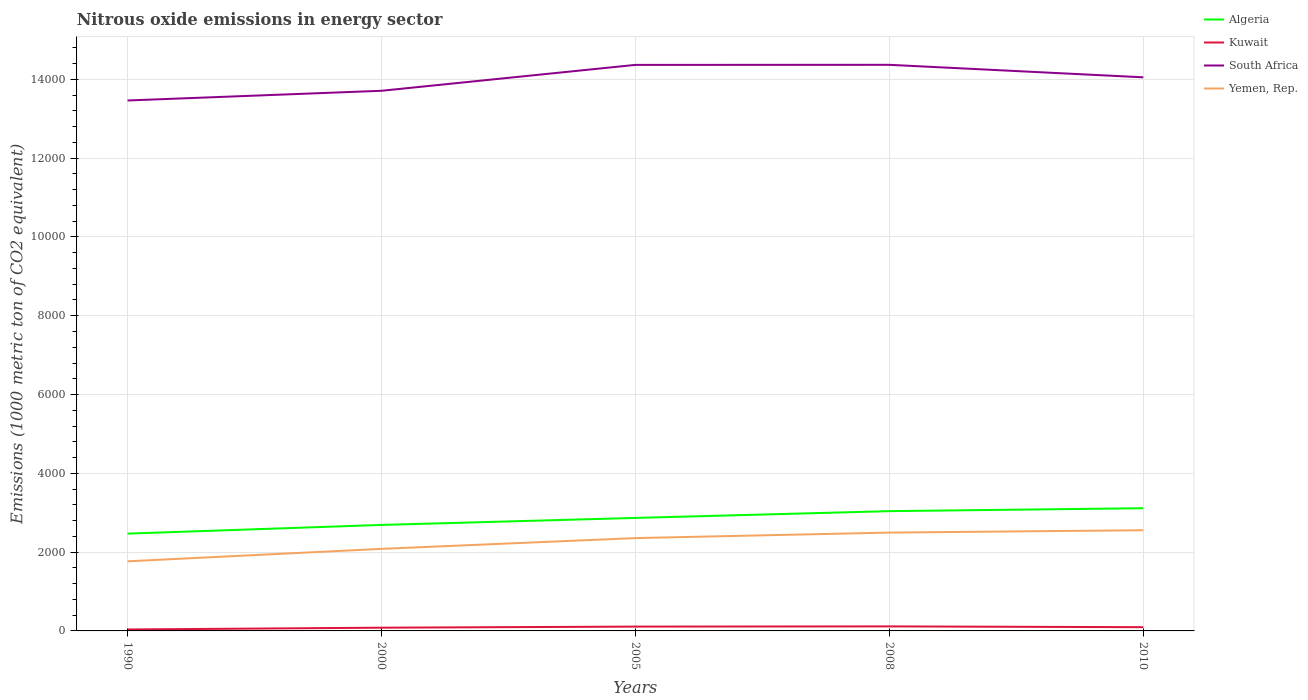Across all years, what is the maximum amount of nitrous oxide emitted in Algeria?
Give a very brief answer. 2469.5. What is the total amount of nitrous oxide emitted in Algeria in the graph?
Provide a succinct answer. -74.5. What is the difference between the highest and the second highest amount of nitrous oxide emitted in Algeria?
Provide a succinct answer. 645.1. How many lines are there?
Offer a very short reply. 4. Are the values on the major ticks of Y-axis written in scientific E-notation?
Your response must be concise. No. Does the graph contain any zero values?
Offer a very short reply. No. Where does the legend appear in the graph?
Your answer should be very brief. Top right. How are the legend labels stacked?
Keep it short and to the point. Vertical. What is the title of the graph?
Offer a terse response. Nitrous oxide emissions in energy sector. Does "Bahrain" appear as one of the legend labels in the graph?
Provide a short and direct response. No. What is the label or title of the X-axis?
Your answer should be compact. Years. What is the label or title of the Y-axis?
Give a very brief answer. Emissions (1000 metric ton of CO2 equivalent). What is the Emissions (1000 metric ton of CO2 equivalent) of Algeria in 1990?
Ensure brevity in your answer.  2469.5. What is the Emissions (1000 metric ton of CO2 equivalent) in Kuwait in 1990?
Provide a succinct answer. 36.7. What is the Emissions (1000 metric ton of CO2 equivalent) of South Africa in 1990?
Make the answer very short. 1.35e+04. What is the Emissions (1000 metric ton of CO2 equivalent) in Yemen, Rep. in 1990?
Make the answer very short. 1766.7. What is the Emissions (1000 metric ton of CO2 equivalent) of Algeria in 2000?
Your answer should be very brief. 2690.4. What is the Emissions (1000 metric ton of CO2 equivalent) in Kuwait in 2000?
Make the answer very short. 81.9. What is the Emissions (1000 metric ton of CO2 equivalent) in South Africa in 2000?
Offer a terse response. 1.37e+04. What is the Emissions (1000 metric ton of CO2 equivalent) in Yemen, Rep. in 2000?
Offer a terse response. 2082.9. What is the Emissions (1000 metric ton of CO2 equivalent) in Algeria in 2005?
Give a very brief answer. 2868.2. What is the Emissions (1000 metric ton of CO2 equivalent) of Kuwait in 2005?
Your answer should be compact. 109.8. What is the Emissions (1000 metric ton of CO2 equivalent) in South Africa in 2005?
Make the answer very short. 1.44e+04. What is the Emissions (1000 metric ton of CO2 equivalent) in Yemen, Rep. in 2005?
Provide a short and direct response. 2356. What is the Emissions (1000 metric ton of CO2 equivalent) of Algeria in 2008?
Give a very brief answer. 3040.1. What is the Emissions (1000 metric ton of CO2 equivalent) of Kuwait in 2008?
Make the answer very short. 114.9. What is the Emissions (1000 metric ton of CO2 equivalent) of South Africa in 2008?
Make the answer very short. 1.44e+04. What is the Emissions (1000 metric ton of CO2 equivalent) of Yemen, Rep. in 2008?
Provide a succinct answer. 2495.7. What is the Emissions (1000 metric ton of CO2 equivalent) in Algeria in 2010?
Your answer should be compact. 3114.6. What is the Emissions (1000 metric ton of CO2 equivalent) of Kuwait in 2010?
Keep it short and to the point. 94.9. What is the Emissions (1000 metric ton of CO2 equivalent) of South Africa in 2010?
Your answer should be compact. 1.41e+04. What is the Emissions (1000 metric ton of CO2 equivalent) of Yemen, Rep. in 2010?
Provide a succinct answer. 2555.7. Across all years, what is the maximum Emissions (1000 metric ton of CO2 equivalent) of Algeria?
Your answer should be compact. 3114.6. Across all years, what is the maximum Emissions (1000 metric ton of CO2 equivalent) of Kuwait?
Your answer should be compact. 114.9. Across all years, what is the maximum Emissions (1000 metric ton of CO2 equivalent) of South Africa?
Give a very brief answer. 1.44e+04. Across all years, what is the maximum Emissions (1000 metric ton of CO2 equivalent) in Yemen, Rep.?
Provide a succinct answer. 2555.7. Across all years, what is the minimum Emissions (1000 metric ton of CO2 equivalent) in Algeria?
Offer a very short reply. 2469.5. Across all years, what is the minimum Emissions (1000 metric ton of CO2 equivalent) in Kuwait?
Offer a very short reply. 36.7. Across all years, what is the minimum Emissions (1000 metric ton of CO2 equivalent) in South Africa?
Offer a very short reply. 1.35e+04. Across all years, what is the minimum Emissions (1000 metric ton of CO2 equivalent) in Yemen, Rep.?
Give a very brief answer. 1766.7. What is the total Emissions (1000 metric ton of CO2 equivalent) in Algeria in the graph?
Ensure brevity in your answer.  1.42e+04. What is the total Emissions (1000 metric ton of CO2 equivalent) in Kuwait in the graph?
Your response must be concise. 438.2. What is the total Emissions (1000 metric ton of CO2 equivalent) in South Africa in the graph?
Your answer should be compact. 7.00e+04. What is the total Emissions (1000 metric ton of CO2 equivalent) in Yemen, Rep. in the graph?
Ensure brevity in your answer.  1.13e+04. What is the difference between the Emissions (1000 metric ton of CO2 equivalent) in Algeria in 1990 and that in 2000?
Give a very brief answer. -220.9. What is the difference between the Emissions (1000 metric ton of CO2 equivalent) in Kuwait in 1990 and that in 2000?
Give a very brief answer. -45.2. What is the difference between the Emissions (1000 metric ton of CO2 equivalent) in South Africa in 1990 and that in 2000?
Ensure brevity in your answer.  -246.5. What is the difference between the Emissions (1000 metric ton of CO2 equivalent) of Yemen, Rep. in 1990 and that in 2000?
Provide a short and direct response. -316.2. What is the difference between the Emissions (1000 metric ton of CO2 equivalent) of Algeria in 1990 and that in 2005?
Provide a short and direct response. -398.7. What is the difference between the Emissions (1000 metric ton of CO2 equivalent) of Kuwait in 1990 and that in 2005?
Provide a succinct answer. -73.1. What is the difference between the Emissions (1000 metric ton of CO2 equivalent) of South Africa in 1990 and that in 2005?
Provide a short and direct response. -903.7. What is the difference between the Emissions (1000 metric ton of CO2 equivalent) of Yemen, Rep. in 1990 and that in 2005?
Keep it short and to the point. -589.3. What is the difference between the Emissions (1000 metric ton of CO2 equivalent) in Algeria in 1990 and that in 2008?
Provide a short and direct response. -570.6. What is the difference between the Emissions (1000 metric ton of CO2 equivalent) of Kuwait in 1990 and that in 2008?
Your answer should be compact. -78.2. What is the difference between the Emissions (1000 metric ton of CO2 equivalent) in South Africa in 1990 and that in 2008?
Offer a very short reply. -905.7. What is the difference between the Emissions (1000 metric ton of CO2 equivalent) in Yemen, Rep. in 1990 and that in 2008?
Offer a terse response. -729. What is the difference between the Emissions (1000 metric ton of CO2 equivalent) in Algeria in 1990 and that in 2010?
Your answer should be very brief. -645.1. What is the difference between the Emissions (1000 metric ton of CO2 equivalent) in Kuwait in 1990 and that in 2010?
Keep it short and to the point. -58.2. What is the difference between the Emissions (1000 metric ton of CO2 equivalent) of South Africa in 1990 and that in 2010?
Give a very brief answer. -588.2. What is the difference between the Emissions (1000 metric ton of CO2 equivalent) of Yemen, Rep. in 1990 and that in 2010?
Your answer should be very brief. -789. What is the difference between the Emissions (1000 metric ton of CO2 equivalent) of Algeria in 2000 and that in 2005?
Offer a very short reply. -177.8. What is the difference between the Emissions (1000 metric ton of CO2 equivalent) in Kuwait in 2000 and that in 2005?
Your answer should be compact. -27.9. What is the difference between the Emissions (1000 metric ton of CO2 equivalent) of South Africa in 2000 and that in 2005?
Keep it short and to the point. -657.2. What is the difference between the Emissions (1000 metric ton of CO2 equivalent) in Yemen, Rep. in 2000 and that in 2005?
Your answer should be very brief. -273.1. What is the difference between the Emissions (1000 metric ton of CO2 equivalent) of Algeria in 2000 and that in 2008?
Provide a succinct answer. -349.7. What is the difference between the Emissions (1000 metric ton of CO2 equivalent) of Kuwait in 2000 and that in 2008?
Give a very brief answer. -33. What is the difference between the Emissions (1000 metric ton of CO2 equivalent) of South Africa in 2000 and that in 2008?
Your response must be concise. -659.2. What is the difference between the Emissions (1000 metric ton of CO2 equivalent) of Yemen, Rep. in 2000 and that in 2008?
Make the answer very short. -412.8. What is the difference between the Emissions (1000 metric ton of CO2 equivalent) of Algeria in 2000 and that in 2010?
Your answer should be compact. -424.2. What is the difference between the Emissions (1000 metric ton of CO2 equivalent) of South Africa in 2000 and that in 2010?
Offer a very short reply. -341.7. What is the difference between the Emissions (1000 metric ton of CO2 equivalent) in Yemen, Rep. in 2000 and that in 2010?
Offer a terse response. -472.8. What is the difference between the Emissions (1000 metric ton of CO2 equivalent) of Algeria in 2005 and that in 2008?
Your response must be concise. -171.9. What is the difference between the Emissions (1000 metric ton of CO2 equivalent) of Kuwait in 2005 and that in 2008?
Ensure brevity in your answer.  -5.1. What is the difference between the Emissions (1000 metric ton of CO2 equivalent) in South Africa in 2005 and that in 2008?
Provide a succinct answer. -2. What is the difference between the Emissions (1000 metric ton of CO2 equivalent) of Yemen, Rep. in 2005 and that in 2008?
Offer a terse response. -139.7. What is the difference between the Emissions (1000 metric ton of CO2 equivalent) of Algeria in 2005 and that in 2010?
Offer a terse response. -246.4. What is the difference between the Emissions (1000 metric ton of CO2 equivalent) of Kuwait in 2005 and that in 2010?
Offer a terse response. 14.9. What is the difference between the Emissions (1000 metric ton of CO2 equivalent) in South Africa in 2005 and that in 2010?
Provide a succinct answer. 315.5. What is the difference between the Emissions (1000 metric ton of CO2 equivalent) of Yemen, Rep. in 2005 and that in 2010?
Make the answer very short. -199.7. What is the difference between the Emissions (1000 metric ton of CO2 equivalent) of Algeria in 2008 and that in 2010?
Make the answer very short. -74.5. What is the difference between the Emissions (1000 metric ton of CO2 equivalent) in Kuwait in 2008 and that in 2010?
Provide a short and direct response. 20. What is the difference between the Emissions (1000 metric ton of CO2 equivalent) in South Africa in 2008 and that in 2010?
Provide a succinct answer. 317.5. What is the difference between the Emissions (1000 metric ton of CO2 equivalent) of Yemen, Rep. in 2008 and that in 2010?
Provide a short and direct response. -60. What is the difference between the Emissions (1000 metric ton of CO2 equivalent) of Algeria in 1990 and the Emissions (1000 metric ton of CO2 equivalent) of Kuwait in 2000?
Offer a very short reply. 2387.6. What is the difference between the Emissions (1000 metric ton of CO2 equivalent) of Algeria in 1990 and the Emissions (1000 metric ton of CO2 equivalent) of South Africa in 2000?
Provide a short and direct response. -1.12e+04. What is the difference between the Emissions (1000 metric ton of CO2 equivalent) of Algeria in 1990 and the Emissions (1000 metric ton of CO2 equivalent) of Yemen, Rep. in 2000?
Give a very brief answer. 386.6. What is the difference between the Emissions (1000 metric ton of CO2 equivalent) of Kuwait in 1990 and the Emissions (1000 metric ton of CO2 equivalent) of South Africa in 2000?
Give a very brief answer. -1.37e+04. What is the difference between the Emissions (1000 metric ton of CO2 equivalent) in Kuwait in 1990 and the Emissions (1000 metric ton of CO2 equivalent) in Yemen, Rep. in 2000?
Provide a succinct answer. -2046.2. What is the difference between the Emissions (1000 metric ton of CO2 equivalent) of South Africa in 1990 and the Emissions (1000 metric ton of CO2 equivalent) of Yemen, Rep. in 2000?
Keep it short and to the point. 1.14e+04. What is the difference between the Emissions (1000 metric ton of CO2 equivalent) of Algeria in 1990 and the Emissions (1000 metric ton of CO2 equivalent) of Kuwait in 2005?
Make the answer very short. 2359.7. What is the difference between the Emissions (1000 metric ton of CO2 equivalent) in Algeria in 1990 and the Emissions (1000 metric ton of CO2 equivalent) in South Africa in 2005?
Make the answer very short. -1.19e+04. What is the difference between the Emissions (1000 metric ton of CO2 equivalent) of Algeria in 1990 and the Emissions (1000 metric ton of CO2 equivalent) of Yemen, Rep. in 2005?
Keep it short and to the point. 113.5. What is the difference between the Emissions (1000 metric ton of CO2 equivalent) in Kuwait in 1990 and the Emissions (1000 metric ton of CO2 equivalent) in South Africa in 2005?
Make the answer very short. -1.43e+04. What is the difference between the Emissions (1000 metric ton of CO2 equivalent) of Kuwait in 1990 and the Emissions (1000 metric ton of CO2 equivalent) of Yemen, Rep. in 2005?
Your answer should be very brief. -2319.3. What is the difference between the Emissions (1000 metric ton of CO2 equivalent) of South Africa in 1990 and the Emissions (1000 metric ton of CO2 equivalent) of Yemen, Rep. in 2005?
Provide a short and direct response. 1.11e+04. What is the difference between the Emissions (1000 metric ton of CO2 equivalent) of Algeria in 1990 and the Emissions (1000 metric ton of CO2 equivalent) of Kuwait in 2008?
Your answer should be compact. 2354.6. What is the difference between the Emissions (1000 metric ton of CO2 equivalent) in Algeria in 1990 and the Emissions (1000 metric ton of CO2 equivalent) in South Africa in 2008?
Make the answer very short. -1.19e+04. What is the difference between the Emissions (1000 metric ton of CO2 equivalent) of Algeria in 1990 and the Emissions (1000 metric ton of CO2 equivalent) of Yemen, Rep. in 2008?
Provide a succinct answer. -26.2. What is the difference between the Emissions (1000 metric ton of CO2 equivalent) of Kuwait in 1990 and the Emissions (1000 metric ton of CO2 equivalent) of South Africa in 2008?
Keep it short and to the point. -1.43e+04. What is the difference between the Emissions (1000 metric ton of CO2 equivalent) of Kuwait in 1990 and the Emissions (1000 metric ton of CO2 equivalent) of Yemen, Rep. in 2008?
Offer a terse response. -2459. What is the difference between the Emissions (1000 metric ton of CO2 equivalent) in South Africa in 1990 and the Emissions (1000 metric ton of CO2 equivalent) in Yemen, Rep. in 2008?
Provide a short and direct response. 1.10e+04. What is the difference between the Emissions (1000 metric ton of CO2 equivalent) in Algeria in 1990 and the Emissions (1000 metric ton of CO2 equivalent) in Kuwait in 2010?
Keep it short and to the point. 2374.6. What is the difference between the Emissions (1000 metric ton of CO2 equivalent) in Algeria in 1990 and the Emissions (1000 metric ton of CO2 equivalent) in South Africa in 2010?
Your answer should be very brief. -1.16e+04. What is the difference between the Emissions (1000 metric ton of CO2 equivalent) of Algeria in 1990 and the Emissions (1000 metric ton of CO2 equivalent) of Yemen, Rep. in 2010?
Offer a terse response. -86.2. What is the difference between the Emissions (1000 metric ton of CO2 equivalent) of Kuwait in 1990 and the Emissions (1000 metric ton of CO2 equivalent) of South Africa in 2010?
Your response must be concise. -1.40e+04. What is the difference between the Emissions (1000 metric ton of CO2 equivalent) in Kuwait in 1990 and the Emissions (1000 metric ton of CO2 equivalent) in Yemen, Rep. in 2010?
Your answer should be compact. -2519. What is the difference between the Emissions (1000 metric ton of CO2 equivalent) of South Africa in 1990 and the Emissions (1000 metric ton of CO2 equivalent) of Yemen, Rep. in 2010?
Your answer should be very brief. 1.09e+04. What is the difference between the Emissions (1000 metric ton of CO2 equivalent) of Algeria in 2000 and the Emissions (1000 metric ton of CO2 equivalent) of Kuwait in 2005?
Give a very brief answer. 2580.6. What is the difference between the Emissions (1000 metric ton of CO2 equivalent) of Algeria in 2000 and the Emissions (1000 metric ton of CO2 equivalent) of South Africa in 2005?
Offer a terse response. -1.17e+04. What is the difference between the Emissions (1000 metric ton of CO2 equivalent) in Algeria in 2000 and the Emissions (1000 metric ton of CO2 equivalent) in Yemen, Rep. in 2005?
Your answer should be very brief. 334.4. What is the difference between the Emissions (1000 metric ton of CO2 equivalent) in Kuwait in 2000 and the Emissions (1000 metric ton of CO2 equivalent) in South Africa in 2005?
Provide a succinct answer. -1.43e+04. What is the difference between the Emissions (1000 metric ton of CO2 equivalent) of Kuwait in 2000 and the Emissions (1000 metric ton of CO2 equivalent) of Yemen, Rep. in 2005?
Your answer should be compact. -2274.1. What is the difference between the Emissions (1000 metric ton of CO2 equivalent) of South Africa in 2000 and the Emissions (1000 metric ton of CO2 equivalent) of Yemen, Rep. in 2005?
Your response must be concise. 1.14e+04. What is the difference between the Emissions (1000 metric ton of CO2 equivalent) in Algeria in 2000 and the Emissions (1000 metric ton of CO2 equivalent) in Kuwait in 2008?
Make the answer very short. 2575.5. What is the difference between the Emissions (1000 metric ton of CO2 equivalent) in Algeria in 2000 and the Emissions (1000 metric ton of CO2 equivalent) in South Africa in 2008?
Your answer should be very brief. -1.17e+04. What is the difference between the Emissions (1000 metric ton of CO2 equivalent) in Algeria in 2000 and the Emissions (1000 metric ton of CO2 equivalent) in Yemen, Rep. in 2008?
Your answer should be compact. 194.7. What is the difference between the Emissions (1000 metric ton of CO2 equivalent) of Kuwait in 2000 and the Emissions (1000 metric ton of CO2 equivalent) of South Africa in 2008?
Offer a terse response. -1.43e+04. What is the difference between the Emissions (1000 metric ton of CO2 equivalent) in Kuwait in 2000 and the Emissions (1000 metric ton of CO2 equivalent) in Yemen, Rep. in 2008?
Ensure brevity in your answer.  -2413.8. What is the difference between the Emissions (1000 metric ton of CO2 equivalent) of South Africa in 2000 and the Emissions (1000 metric ton of CO2 equivalent) of Yemen, Rep. in 2008?
Offer a very short reply. 1.12e+04. What is the difference between the Emissions (1000 metric ton of CO2 equivalent) of Algeria in 2000 and the Emissions (1000 metric ton of CO2 equivalent) of Kuwait in 2010?
Keep it short and to the point. 2595.5. What is the difference between the Emissions (1000 metric ton of CO2 equivalent) of Algeria in 2000 and the Emissions (1000 metric ton of CO2 equivalent) of South Africa in 2010?
Offer a terse response. -1.14e+04. What is the difference between the Emissions (1000 metric ton of CO2 equivalent) of Algeria in 2000 and the Emissions (1000 metric ton of CO2 equivalent) of Yemen, Rep. in 2010?
Your answer should be very brief. 134.7. What is the difference between the Emissions (1000 metric ton of CO2 equivalent) of Kuwait in 2000 and the Emissions (1000 metric ton of CO2 equivalent) of South Africa in 2010?
Make the answer very short. -1.40e+04. What is the difference between the Emissions (1000 metric ton of CO2 equivalent) of Kuwait in 2000 and the Emissions (1000 metric ton of CO2 equivalent) of Yemen, Rep. in 2010?
Your answer should be compact. -2473.8. What is the difference between the Emissions (1000 metric ton of CO2 equivalent) of South Africa in 2000 and the Emissions (1000 metric ton of CO2 equivalent) of Yemen, Rep. in 2010?
Provide a succinct answer. 1.12e+04. What is the difference between the Emissions (1000 metric ton of CO2 equivalent) of Algeria in 2005 and the Emissions (1000 metric ton of CO2 equivalent) of Kuwait in 2008?
Provide a short and direct response. 2753.3. What is the difference between the Emissions (1000 metric ton of CO2 equivalent) of Algeria in 2005 and the Emissions (1000 metric ton of CO2 equivalent) of South Africa in 2008?
Ensure brevity in your answer.  -1.15e+04. What is the difference between the Emissions (1000 metric ton of CO2 equivalent) of Algeria in 2005 and the Emissions (1000 metric ton of CO2 equivalent) of Yemen, Rep. in 2008?
Offer a very short reply. 372.5. What is the difference between the Emissions (1000 metric ton of CO2 equivalent) in Kuwait in 2005 and the Emissions (1000 metric ton of CO2 equivalent) in South Africa in 2008?
Keep it short and to the point. -1.43e+04. What is the difference between the Emissions (1000 metric ton of CO2 equivalent) in Kuwait in 2005 and the Emissions (1000 metric ton of CO2 equivalent) in Yemen, Rep. in 2008?
Give a very brief answer. -2385.9. What is the difference between the Emissions (1000 metric ton of CO2 equivalent) of South Africa in 2005 and the Emissions (1000 metric ton of CO2 equivalent) of Yemen, Rep. in 2008?
Provide a succinct answer. 1.19e+04. What is the difference between the Emissions (1000 metric ton of CO2 equivalent) in Algeria in 2005 and the Emissions (1000 metric ton of CO2 equivalent) in Kuwait in 2010?
Make the answer very short. 2773.3. What is the difference between the Emissions (1000 metric ton of CO2 equivalent) of Algeria in 2005 and the Emissions (1000 metric ton of CO2 equivalent) of South Africa in 2010?
Give a very brief answer. -1.12e+04. What is the difference between the Emissions (1000 metric ton of CO2 equivalent) in Algeria in 2005 and the Emissions (1000 metric ton of CO2 equivalent) in Yemen, Rep. in 2010?
Ensure brevity in your answer.  312.5. What is the difference between the Emissions (1000 metric ton of CO2 equivalent) of Kuwait in 2005 and the Emissions (1000 metric ton of CO2 equivalent) of South Africa in 2010?
Offer a terse response. -1.39e+04. What is the difference between the Emissions (1000 metric ton of CO2 equivalent) in Kuwait in 2005 and the Emissions (1000 metric ton of CO2 equivalent) in Yemen, Rep. in 2010?
Make the answer very short. -2445.9. What is the difference between the Emissions (1000 metric ton of CO2 equivalent) in South Africa in 2005 and the Emissions (1000 metric ton of CO2 equivalent) in Yemen, Rep. in 2010?
Make the answer very short. 1.18e+04. What is the difference between the Emissions (1000 metric ton of CO2 equivalent) of Algeria in 2008 and the Emissions (1000 metric ton of CO2 equivalent) of Kuwait in 2010?
Keep it short and to the point. 2945.2. What is the difference between the Emissions (1000 metric ton of CO2 equivalent) in Algeria in 2008 and the Emissions (1000 metric ton of CO2 equivalent) in South Africa in 2010?
Provide a short and direct response. -1.10e+04. What is the difference between the Emissions (1000 metric ton of CO2 equivalent) of Algeria in 2008 and the Emissions (1000 metric ton of CO2 equivalent) of Yemen, Rep. in 2010?
Ensure brevity in your answer.  484.4. What is the difference between the Emissions (1000 metric ton of CO2 equivalent) of Kuwait in 2008 and the Emissions (1000 metric ton of CO2 equivalent) of South Africa in 2010?
Make the answer very short. -1.39e+04. What is the difference between the Emissions (1000 metric ton of CO2 equivalent) in Kuwait in 2008 and the Emissions (1000 metric ton of CO2 equivalent) in Yemen, Rep. in 2010?
Give a very brief answer. -2440.8. What is the difference between the Emissions (1000 metric ton of CO2 equivalent) in South Africa in 2008 and the Emissions (1000 metric ton of CO2 equivalent) in Yemen, Rep. in 2010?
Your answer should be compact. 1.18e+04. What is the average Emissions (1000 metric ton of CO2 equivalent) of Algeria per year?
Your response must be concise. 2836.56. What is the average Emissions (1000 metric ton of CO2 equivalent) in Kuwait per year?
Make the answer very short. 87.64. What is the average Emissions (1000 metric ton of CO2 equivalent) in South Africa per year?
Make the answer very short. 1.40e+04. What is the average Emissions (1000 metric ton of CO2 equivalent) of Yemen, Rep. per year?
Keep it short and to the point. 2251.4. In the year 1990, what is the difference between the Emissions (1000 metric ton of CO2 equivalent) of Algeria and Emissions (1000 metric ton of CO2 equivalent) of Kuwait?
Offer a terse response. 2432.8. In the year 1990, what is the difference between the Emissions (1000 metric ton of CO2 equivalent) in Algeria and Emissions (1000 metric ton of CO2 equivalent) in South Africa?
Your response must be concise. -1.10e+04. In the year 1990, what is the difference between the Emissions (1000 metric ton of CO2 equivalent) in Algeria and Emissions (1000 metric ton of CO2 equivalent) in Yemen, Rep.?
Keep it short and to the point. 702.8. In the year 1990, what is the difference between the Emissions (1000 metric ton of CO2 equivalent) in Kuwait and Emissions (1000 metric ton of CO2 equivalent) in South Africa?
Provide a succinct answer. -1.34e+04. In the year 1990, what is the difference between the Emissions (1000 metric ton of CO2 equivalent) in Kuwait and Emissions (1000 metric ton of CO2 equivalent) in Yemen, Rep.?
Keep it short and to the point. -1730. In the year 1990, what is the difference between the Emissions (1000 metric ton of CO2 equivalent) of South Africa and Emissions (1000 metric ton of CO2 equivalent) of Yemen, Rep.?
Ensure brevity in your answer.  1.17e+04. In the year 2000, what is the difference between the Emissions (1000 metric ton of CO2 equivalent) of Algeria and Emissions (1000 metric ton of CO2 equivalent) of Kuwait?
Ensure brevity in your answer.  2608.5. In the year 2000, what is the difference between the Emissions (1000 metric ton of CO2 equivalent) in Algeria and Emissions (1000 metric ton of CO2 equivalent) in South Africa?
Your answer should be compact. -1.10e+04. In the year 2000, what is the difference between the Emissions (1000 metric ton of CO2 equivalent) of Algeria and Emissions (1000 metric ton of CO2 equivalent) of Yemen, Rep.?
Offer a terse response. 607.5. In the year 2000, what is the difference between the Emissions (1000 metric ton of CO2 equivalent) of Kuwait and Emissions (1000 metric ton of CO2 equivalent) of South Africa?
Provide a succinct answer. -1.36e+04. In the year 2000, what is the difference between the Emissions (1000 metric ton of CO2 equivalent) of Kuwait and Emissions (1000 metric ton of CO2 equivalent) of Yemen, Rep.?
Your response must be concise. -2001. In the year 2000, what is the difference between the Emissions (1000 metric ton of CO2 equivalent) in South Africa and Emissions (1000 metric ton of CO2 equivalent) in Yemen, Rep.?
Offer a very short reply. 1.16e+04. In the year 2005, what is the difference between the Emissions (1000 metric ton of CO2 equivalent) of Algeria and Emissions (1000 metric ton of CO2 equivalent) of Kuwait?
Give a very brief answer. 2758.4. In the year 2005, what is the difference between the Emissions (1000 metric ton of CO2 equivalent) in Algeria and Emissions (1000 metric ton of CO2 equivalent) in South Africa?
Make the answer very short. -1.15e+04. In the year 2005, what is the difference between the Emissions (1000 metric ton of CO2 equivalent) in Algeria and Emissions (1000 metric ton of CO2 equivalent) in Yemen, Rep.?
Keep it short and to the point. 512.2. In the year 2005, what is the difference between the Emissions (1000 metric ton of CO2 equivalent) of Kuwait and Emissions (1000 metric ton of CO2 equivalent) of South Africa?
Provide a succinct answer. -1.43e+04. In the year 2005, what is the difference between the Emissions (1000 metric ton of CO2 equivalent) of Kuwait and Emissions (1000 metric ton of CO2 equivalent) of Yemen, Rep.?
Keep it short and to the point. -2246.2. In the year 2005, what is the difference between the Emissions (1000 metric ton of CO2 equivalent) in South Africa and Emissions (1000 metric ton of CO2 equivalent) in Yemen, Rep.?
Your answer should be compact. 1.20e+04. In the year 2008, what is the difference between the Emissions (1000 metric ton of CO2 equivalent) in Algeria and Emissions (1000 metric ton of CO2 equivalent) in Kuwait?
Make the answer very short. 2925.2. In the year 2008, what is the difference between the Emissions (1000 metric ton of CO2 equivalent) of Algeria and Emissions (1000 metric ton of CO2 equivalent) of South Africa?
Your answer should be compact. -1.13e+04. In the year 2008, what is the difference between the Emissions (1000 metric ton of CO2 equivalent) in Algeria and Emissions (1000 metric ton of CO2 equivalent) in Yemen, Rep.?
Offer a terse response. 544.4. In the year 2008, what is the difference between the Emissions (1000 metric ton of CO2 equivalent) of Kuwait and Emissions (1000 metric ton of CO2 equivalent) of South Africa?
Offer a very short reply. -1.43e+04. In the year 2008, what is the difference between the Emissions (1000 metric ton of CO2 equivalent) in Kuwait and Emissions (1000 metric ton of CO2 equivalent) in Yemen, Rep.?
Give a very brief answer. -2380.8. In the year 2008, what is the difference between the Emissions (1000 metric ton of CO2 equivalent) in South Africa and Emissions (1000 metric ton of CO2 equivalent) in Yemen, Rep.?
Your response must be concise. 1.19e+04. In the year 2010, what is the difference between the Emissions (1000 metric ton of CO2 equivalent) in Algeria and Emissions (1000 metric ton of CO2 equivalent) in Kuwait?
Your answer should be very brief. 3019.7. In the year 2010, what is the difference between the Emissions (1000 metric ton of CO2 equivalent) in Algeria and Emissions (1000 metric ton of CO2 equivalent) in South Africa?
Your answer should be very brief. -1.09e+04. In the year 2010, what is the difference between the Emissions (1000 metric ton of CO2 equivalent) of Algeria and Emissions (1000 metric ton of CO2 equivalent) of Yemen, Rep.?
Your answer should be compact. 558.9. In the year 2010, what is the difference between the Emissions (1000 metric ton of CO2 equivalent) of Kuwait and Emissions (1000 metric ton of CO2 equivalent) of South Africa?
Make the answer very short. -1.40e+04. In the year 2010, what is the difference between the Emissions (1000 metric ton of CO2 equivalent) of Kuwait and Emissions (1000 metric ton of CO2 equivalent) of Yemen, Rep.?
Your answer should be compact. -2460.8. In the year 2010, what is the difference between the Emissions (1000 metric ton of CO2 equivalent) in South Africa and Emissions (1000 metric ton of CO2 equivalent) in Yemen, Rep.?
Ensure brevity in your answer.  1.15e+04. What is the ratio of the Emissions (1000 metric ton of CO2 equivalent) of Algeria in 1990 to that in 2000?
Ensure brevity in your answer.  0.92. What is the ratio of the Emissions (1000 metric ton of CO2 equivalent) in Kuwait in 1990 to that in 2000?
Your answer should be compact. 0.45. What is the ratio of the Emissions (1000 metric ton of CO2 equivalent) in South Africa in 1990 to that in 2000?
Ensure brevity in your answer.  0.98. What is the ratio of the Emissions (1000 metric ton of CO2 equivalent) in Yemen, Rep. in 1990 to that in 2000?
Your answer should be very brief. 0.85. What is the ratio of the Emissions (1000 metric ton of CO2 equivalent) of Algeria in 1990 to that in 2005?
Give a very brief answer. 0.86. What is the ratio of the Emissions (1000 metric ton of CO2 equivalent) in Kuwait in 1990 to that in 2005?
Provide a succinct answer. 0.33. What is the ratio of the Emissions (1000 metric ton of CO2 equivalent) in South Africa in 1990 to that in 2005?
Provide a short and direct response. 0.94. What is the ratio of the Emissions (1000 metric ton of CO2 equivalent) in Yemen, Rep. in 1990 to that in 2005?
Offer a very short reply. 0.75. What is the ratio of the Emissions (1000 metric ton of CO2 equivalent) in Algeria in 1990 to that in 2008?
Offer a terse response. 0.81. What is the ratio of the Emissions (1000 metric ton of CO2 equivalent) of Kuwait in 1990 to that in 2008?
Offer a terse response. 0.32. What is the ratio of the Emissions (1000 metric ton of CO2 equivalent) of South Africa in 1990 to that in 2008?
Offer a very short reply. 0.94. What is the ratio of the Emissions (1000 metric ton of CO2 equivalent) of Yemen, Rep. in 1990 to that in 2008?
Offer a terse response. 0.71. What is the ratio of the Emissions (1000 metric ton of CO2 equivalent) in Algeria in 1990 to that in 2010?
Offer a terse response. 0.79. What is the ratio of the Emissions (1000 metric ton of CO2 equivalent) of Kuwait in 1990 to that in 2010?
Make the answer very short. 0.39. What is the ratio of the Emissions (1000 metric ton of CO2 equivalent) in South Africa in 1990 to that in 2010?
Provide a short and direct response. 0.96. What is the ratio of the Emissions (1000 metric ton of CO2 equivalent) in Yemen, Rep. in 1990 to that in 2010?
Ensure brevity in your answer.  0.69. What is the ratio of the Emissions (1000 metric ton of CO2 equivalent) of Algeria in 2000 to that in 2005?
Your response must be concise. 0.94. What is the ratio of the Emissions (1000 metric ton of CO2 equivalent) of Kuwait in 2000 to that in 2005?
Provide a succinct answer. 0.75. What is the ratio of the Emissions (1000 metric ton of CO2 equivalent) of South Africa in 2000 to that in 2005?
Your response must be concise. 0.95. What is the ratio of the Emissions (1000 metric ton of CO2 equivalent) in Yemen, Rep. in 2000 to that in 2005?
Ensure brevity in your answer.  0.88. What is the ratio of the Emissions (1000 metric ton of CO2 equivalent) in Algeria in 2000 to that in 2008?
Provide a short and direct response. 0.89. What is the ratio of the Emissions (1000 metric ton of CO2 equivalent) in Kuwait in 2000 to that in 2008?
Ensure brevity in your answer.  0.71. What is the ratio of the Emissions (1000 metric ton of CO2 equivalent) of South Africa in 2000 to that in 2008?
Your answer should be very brief. 0.95. What is the ratio of the Emissions (1000 metric ton of CO2 equivalent) of Yemen, Rep. in 2000 to that in 2008?
Your response must be concise. 0.83. What is the ratio of the Emissions (1000 metric ton of CO2 equivalent) in Algeria in 2000 to that in 2010?
Your answer should be very brief. 0.86. What is the ratio of the Emissions (1000 metric ton of CO2 equivalent) in Kuwait in 2000 to that in 2010?
Ensure brevity in your answer.  0.86. What is the ratio of the Emissions (1000 metric ton of CO2 equivalent) in South Africa in 2000 to that in 2010?
Ensure brevity in your answer.  0.98. What is the ratio of the Emissions (1000 metric ton of CO2 equivalent) of Yemen, Rep. in 2000 to that in 2010?
Offer a terse response. 0.81. What is the ratio of the Emissions (1000 metric ton of CO2 equivalent) of Algeria in 2005 to that in 2008?
Your answer should be very brief. 0.94. What is the ratio of the Emissions (1000 metric ton of CO2 equivalent) in Kuwait in 2005 to that in 2008?
Provide a succinct answer. 0.96. What is the ratio of the Emissions (1000 metric ton of CO2 equivalent) in Yemen, Rep. in 2005 to that in 2008?
Give a very brief answer. 0.94. What is the ratio of the Emissions (1000 metric ton of CO2 equivalent) of Algeria in 2005 to that in 2010?
Make the answer very short. 0.92. What is the ratio of the Emissions (1000 metric ton of CO2 equivalent) of Kuwait in 2005 to that in 2010?
Give a very brief answer. 1.16. What is the ratio of the Emissions (1000 metric ton of CO2 equivalent) in South Africa in 2005 to that in 2010?
Your response must be concise. 1.02. What is the ratio of the Emissions (1000 metric ton of CO2 equivalent) of Yemen, Rep. in 2005 to that in 2010?
Your answer should be compact. 0.92. What is the ratio of the Emissions (1000 metric ton of CO2 equivalent) of Algeria in 2008 to that in 2010?
Provide a succinct answer. 0.98. What is the ratio of the Emissions (1000 metric ton of CO2 equivalent) of Kuwait in 2008 to that in 2010?
Keep it short and to the point. 1.21. What is the ratio of the Emissions (1000 metric ton of CO2 equivalent) in South Africa in 2008 to that in 2010?
Offer a terse response. 1.02. What is the ratio of the Emissions (1000 metric ton of CO2 equivalent) of Yemen, Rep. in 2008 to that in 2010?
Give a very brief answer. 0.98. What is the difference between the highest and the second highest Emissions (1000 metric ton of CO2 equivalent) of Algeria?
Your response must be concise. 74.5. What is the difference between the highest and the second highest Emissions (1000 metric ton of CO2 equivalent) in Yemen, Rep.?
Make the answer very short. 60. What is the difference between the highest and the lowest Emissions (1000 metric ton of CO2 equivalent) in Algeria?
Offer a terse response. 645.1. What is the difference between the highest and the lowest Emissions (1000 metric ton of CO2 equivalent) in Kuwait?
Your response must be concise. 78.2. What is the difference between the highest and the lowest Emissions (1000 metric ton of CO2 equivalent) in South Africa?
Provide a succinct answer. 905.7. What is the difference between the highest and the lowest Emissions (1000 metric ton of CO2 equivalent) of Yemen, Rep.?
Keep it short and to the point. 789. 